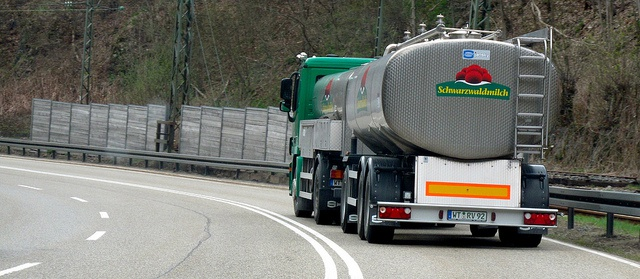Describe the objects in this image and their specific colors. I can see a truck in black, gray, darkgray, and lightgray tones in this image. 